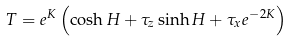Convert formula to latex. <formula><loc_0><loc_0><loc_500><loc_500>T = e ^ { K } \left ( \cosh H + \tau _ { z } \sinh H + \tau _ { x } e ^ { - 2 K } \right )</formula> 